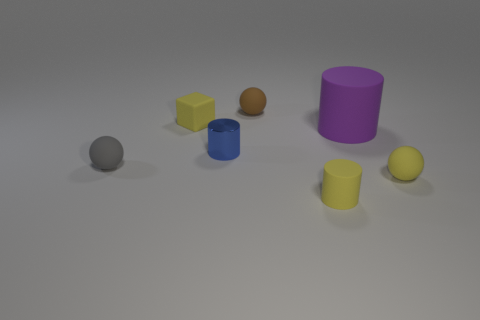There is a gray object behind the tiny cylinder in front of the tiny blue cylinder; what is its shape?
Keep it short and to the point. Sphere. What number of matte blocks are to the right of the yellow rubber thing in front of the small yellow sphere?
Keep it short and to the point. 0. There is a tiny sphere that is both on the right side of the tiny blue cylinder and in front of the blue cylinder; what is it made of?
Offer a very short reply. Rubber. What shape is the gray thing that is the same size as the blue metallic object?
Provide a succinct answer. Sphere. What color is the rubber ball on the left side of the tiny blue cylinder behind the small rubber sphere on the right side of the large purple rubber cylinder?
Your response must be concise. Gray. What number of objects are matte objects that are behind the small gray object or tiny green balls?
Your response must be concise. 3. There is a yellow cube that is the same size as the yellow rubber cylinder; what is it made of?
Offer a terse response. Rubber. There is a yellow thing to the left of the small cylinder in front of the small rubber ball that is on the right side of the large rubber cylinder; what is its material?
Give a very brief answer. Rubber. What is the color of the metallic cylinder?
Provide a succinct answer. Blue. What number of tiny things are either blue shiny cylinders or purple cylinders?
Provide a succinct answer. 1. 